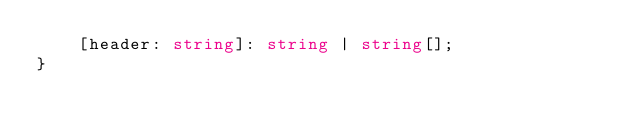<code> <loc_0><loc_0><loc_500><loc_500><_TypeScript_>    [header: string]: string | string[];
}
</code> 